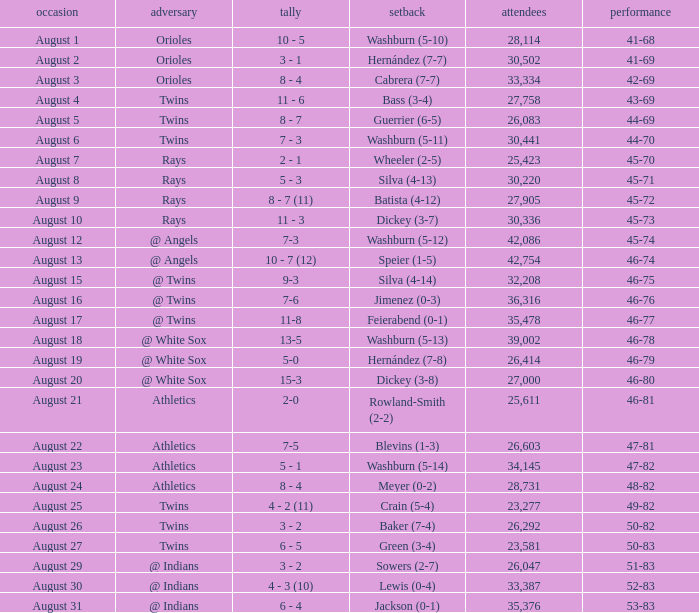What was the loss for August 19? Hernández (7-8). 